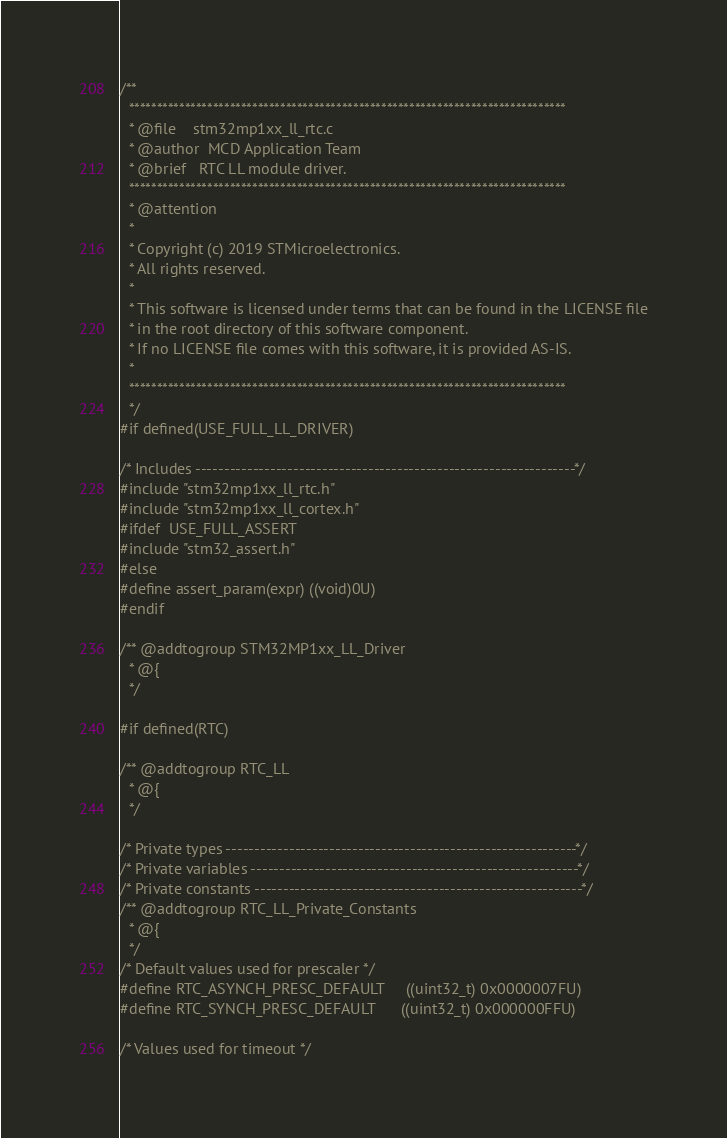Convert code to text. <code><loc_0><loc_0><loc_500><loc_500><_C_>/**
  ******************************************************************************
  * @file    stm32mp1xx_ll_rtc.c
  * @author  MCD Application Team
  * @brief   RTC LL module driver.
  ******************************************************************************
  * @attention
  *
  * Copyright (c) 2019 STMicroelectronics.
  * All rights reserved.
  *
  * This software is licensed under terms that can be found in the LICENSE file
  * in the root directory of this software component.
  * If no LICENSE file comes with this software, it is provided AS-IS.
  *
  ******************************************************************************
  */
#if defined(USE_FULL_LL_DRIVER)

/* Includes ------------------------------------------------------------------*/
#include "stm32mp1xx_ll_rtc.h"
#include "stm32mp1xx_ll_cortex.h"
#ifdef  USE_FULL_ASSERT
#include "stm32_assert.h"
#else
#define assert_param(expr) ((void)0U)
#endif

/** @addtogroup STM32MP1xx_LL_Driver
  * @{
  */

#if defined(RTC)

/** @addtogroup RTC_LL
  * @{
  */

/* Private types -------------------------------------------------------------*/
/* Private variables ---------------------------------------------------------*/
/* Private constants ---------------------------------------------------------*/
/** @addtogroup RTC_LL_Private_Constants
  * @{
  */
/* Default values used for prescaler */
#define RTC_ASYNCH_PRESC_DEFAULT     ((uint32_t) 0x0000007FU)
#define RTC_SYNCH_PRESC_DEFAULT      ((uint32_t) 0x000000FFU)

/* Values used for timeout */</code> 